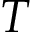Convert formula to latex. <formula><loc_0><loc_0><loc_500><loc_500>T</formula> 